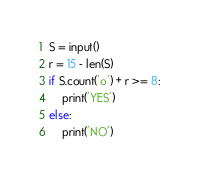<code> <loc_0><loc_0><loc_500><loc_500><_Python_>S = input()
r = 15 - len(S)
if S.count('o') + r >= 8:
    print('YES')
else:
    print('NO')
</code> 